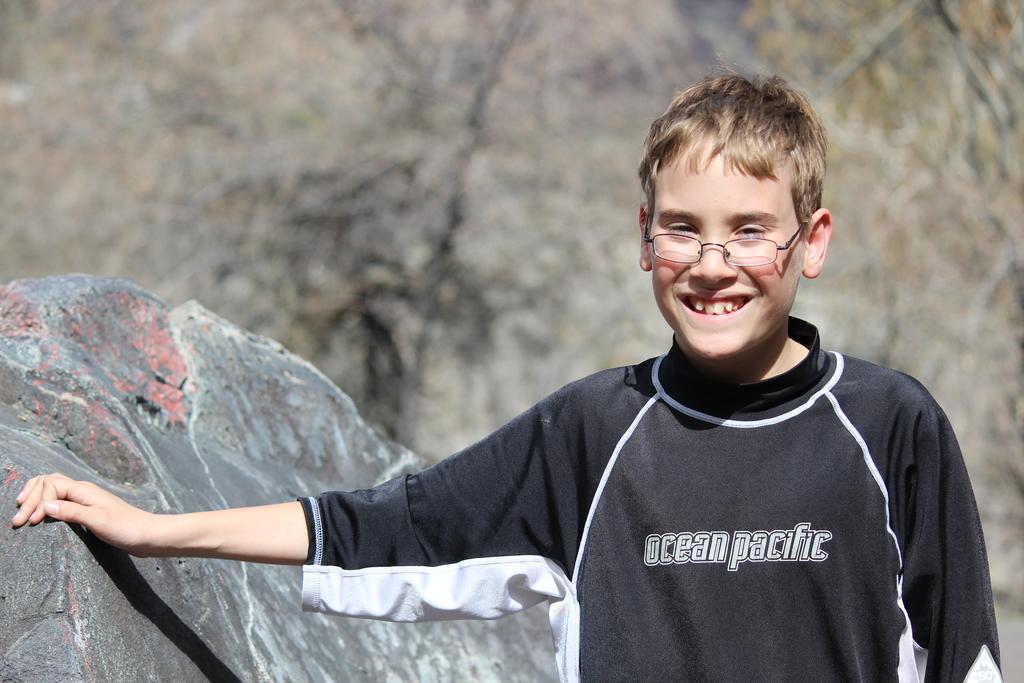What brand is the kid's shirt?
Provide a short and direct response. Ocean pacific. 